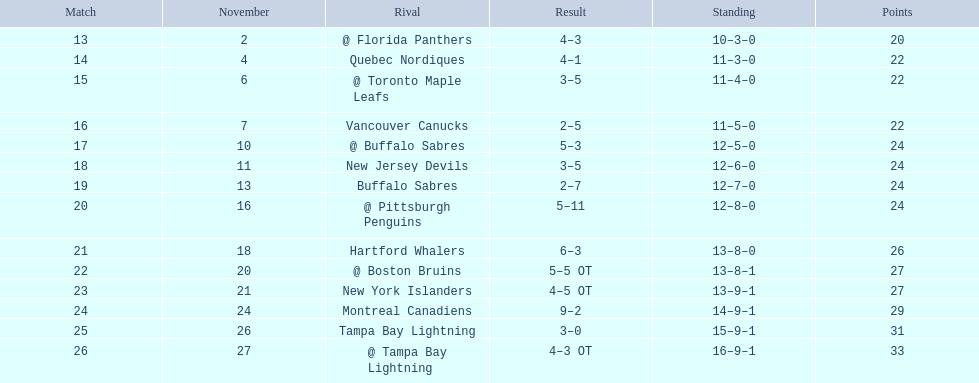What are the teams in the atlantic division? Quebec Nordiques, Vancouver Canucks, New Jersey Devils, Buffalo Sabres, Hartford Whalers, New York Islanders, Montreal Canadiens, Tampa Bay Lightning. Which of those scored fewer points than the philadelphia flyers? Tampa Bay Lightning. 